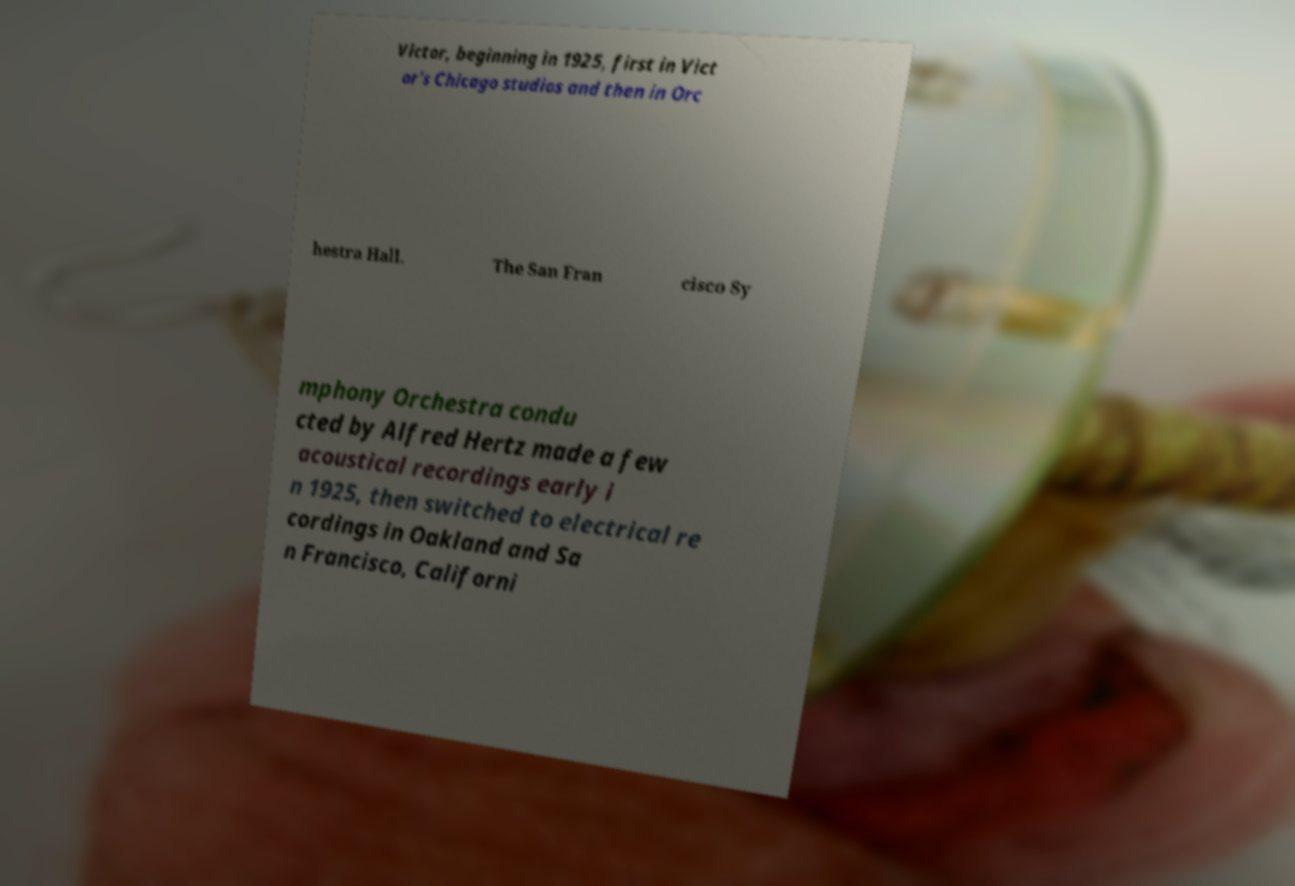Could you assist in decoding the text presented in this image and type it out clearly? Victor, beginning in 1925, first in Vict or's Chicago studios and then in Orc hestra Hall. The San Fran cisco Sy mphony Orchestra condu cted by Alfred Hertz made a few acoustical recordings early i n 1925, then switched to electrical re cordings in Oakland and Sa n Francisco, Californi 